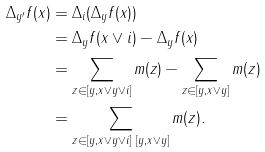Convert formula to latex. <formula><loc_0><loc_0><loc_500><loc_500>\Delta _ { y ^ { \prime } } f ( x ) & = \Delta _ { i } ( \Delta _ { y } f ( x ) ) \\ & = \Delta _ { y } f ( x \vee i ) - \Delta _ { y } f ( x ) \\ & = \sum _ { z \in [ y , x \vee y \vee i ] } m ( z ) - \sum _ { z \in [ y , x \vee y ] } m ( z ) \\ & = \sum _ { z \in [ y , x \vee y \vee i ] \ [ y , x \vee y ] } m ( z ) .</formula> 